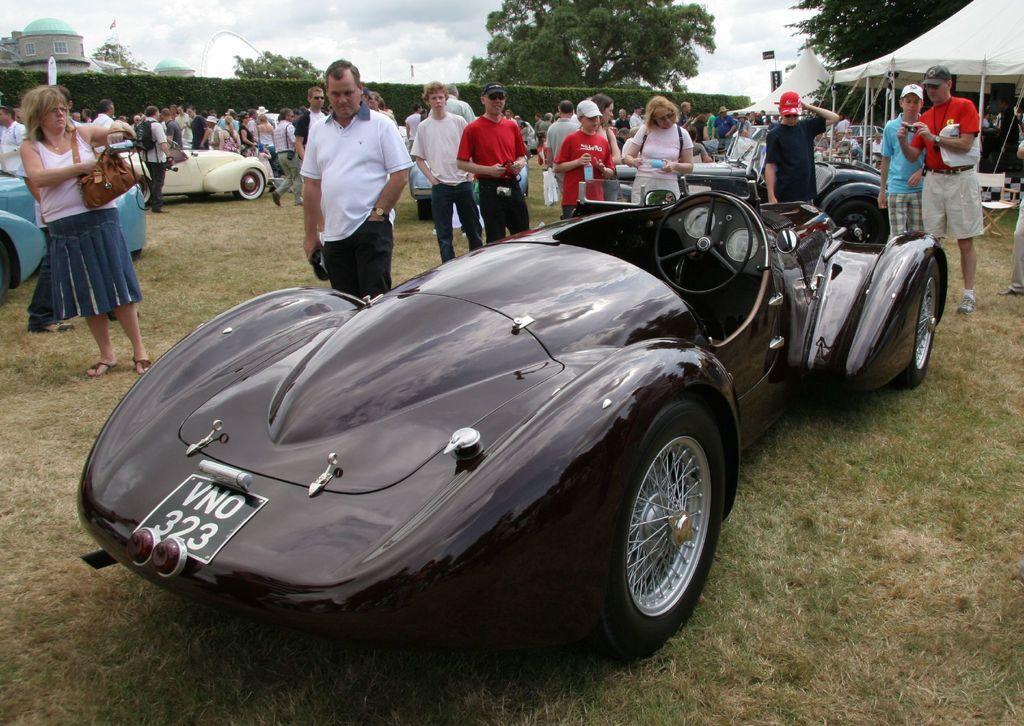How would you summarize this image in a sentence or two? In this picture we can see some vehicles are parked on the path and a group of people are standing on the path. Behind the people there is a stall, trees, buildings and a cloudy sky. 